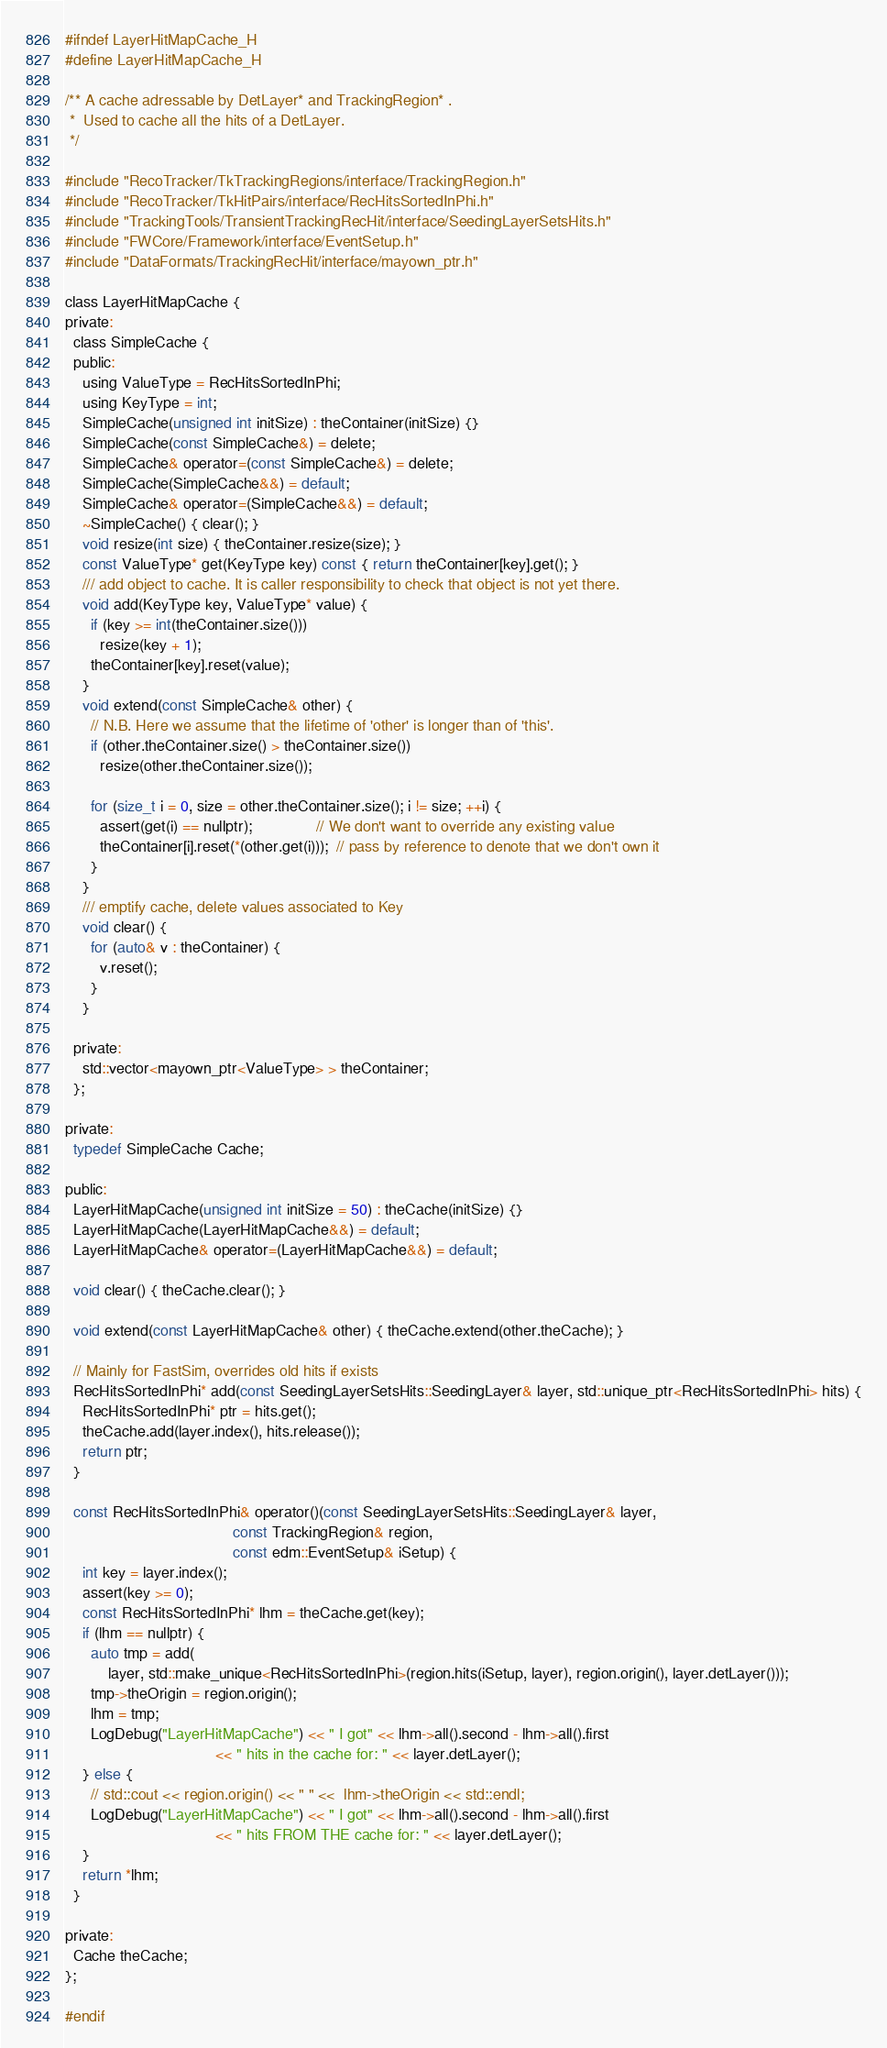Convert code to text. <code><loc_0><loc_0><loc_500><loc_500><_C_>#ifndef LayerHitMapCache_H
#define LayerHitMapCache_H

/** A cache adressable by DetLayer* and TrackingRegion* .
 *  Used to cache all the hits of a DetLayer.
 */

#include "RecoTracker/TkTrackingRegions/interface/TrackingRegion.h"
#include "RecoTracker/TkHitPairs/interface/RecHitsSortedInPhi.h"
#include "TrackingTools/TransientTrackingRecHit/interface/SeedingLayerSetsHits.h"
#include "FWCore/Framework/interface/EventSetup.h"
#include "DataFormats/TrackingRecHit/interface/mayown_ptr.h"

class LayerHitMapCache {
private:
  class SimpleCache {
  public:
    using ValueType = RecHitsSortedInPhi;
    using KeyType = int;
    SimpleCache(unsigned int initSize) : theContainer(initSize) {}
    SimpleCache(const SimpleCache&) = delete;
    SimpleCache& operator=(const SimpleCache&) = delete;
    SimpleCache(SimpleCache&&) = default;
    SimpleCache& operator=(SimpleCache&&) = default;
    ~SimpleCache() { clear(); }
    void resize(int size) { theContainer.resize(size); }
    const ValueType* get(KeyType key) const { return theContainer[key].get(); }
    /// add object to cache. It is caller responsibility to check that object is not yet there.
    void add(KeyType key, ValueType* value) {
      if (key >= int(theContainer.size()))
        resize(key + 1);
      theContainer[key].reset(value);
    }
    void extend(const SimpleCache& other) {
      // N.B. Here we assume that the lifetime of 'other' is longer than of 'this'.
      if (other.theContainer.size() > theContainer.size())
        resize(other.theContainer.size());

      for (size_t i = 0, size = other.theContainer.size(); i != size; ++i) {
        assert(get(i) == nullptr);               // We don't want to override any existing value
        theContainer[i].reset(*(other.get(i)));  // pass by reference to denote that we don't own it
      }
    }
    /// emptify cache, delete values associated to Key
    void clear() {
      for (auto& v : theContainer) {
        v.reset();
      }
    }

  private:
    std::vector<mayown_ptr<ValueType> > theContainer;
  };

private:
  typedef SimpleCache Cache;

public:
  LayerHitMapCache(unsigned int initSize = 50) : theCache(initSize) {}
  LayerHitMapCache(LayerHitMapCache&&) = default;
  LayerHitMapCache& operator=(LayerHitMapCache&&) = default;

  void clear() { theCache.clear(); }

  void extend(const LayerHitMapCache& other) { theCache.extend(other.theCache); }

  // Mainly for FastSim, overrides old hits if exists
  RecHitsSortedInPhi* add(const SeedingLayerSetsHits::SeedingLayer& layer, std::unique_ptr<RecHitsSortedInPhi> hits) {
    RecHitsSortedInPhi* ptr = hits.get();
    theCache.add(layer.index(), hits.release());
    return ptr;
  }

  const RecHitsSortedInPhi& operator()(const SeedingLayerSetsHits::SeedingLayer& layer,
                                       const TrackingRegion& region,
                                       const edm::EventSetup& iSetup) {
    int key = layer.index();
    assert(key >= 0);
    const RecHitsSortedInPhi* lhm = theCache.get(key);
    if (lhm == nullptr) {
      auto tmp = add(
          layer, std::make_unique<RecHitsSortedInPhi>(region.hits(iSetup, layer), region.origin(), layer.detLayer()));
      tmp->theOrigin = region.origin();
      lhm = tmp;
      LogDebug("LayerHitMapCache") << " I got" << lhm->all().second - lhm->all().first
                                   << " hits in the cache for: " << layer.detLayer();
    } else {
      // std::cout << region.origin() << " " <<  lhm->theOrigin << std::endl;
      LogDebug("LayerHitMapCache") << " I got" << lhm->all().second - lhm->all().first
                                   << " hits FROM THE cache for: " << layer.detLayer();
    }
    return *lhm;
  }

private:
  Cache theCache;
};

#endif
</code> 